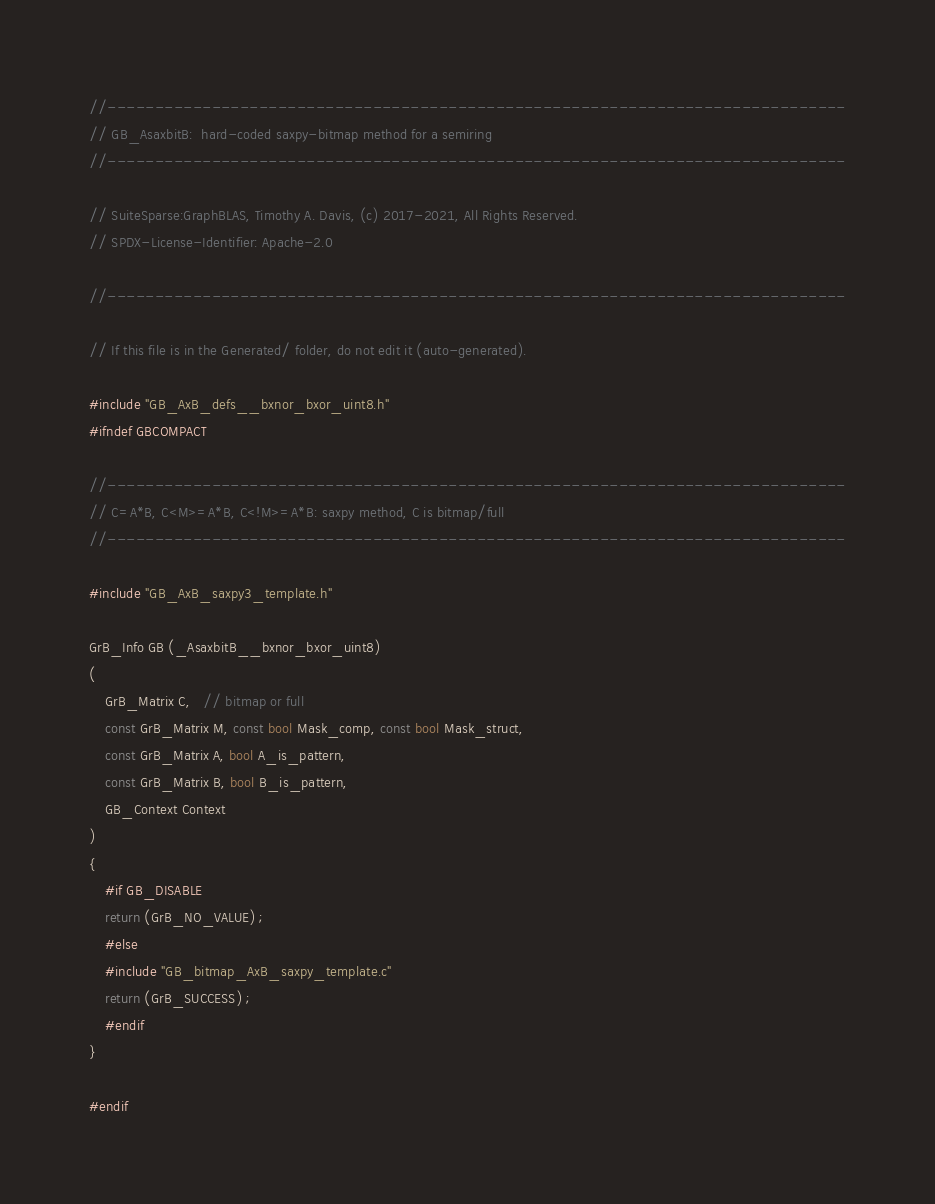Convert code to text. <code><loc_0><loc_0><loc_500><loc_500><_C_>//------------------------------------------------------------------------------
// GB_AsaxbitB:  hard-coded saxpy-bitmap method for a semiring
//------------------------------------------------------------------------------

// SuiteSparse:GraphBLAS, Timothy A. Davis, (c) 2017-2021, All Rights Reserved.
// SPDX-License-Identifier: Apache-2.0

//------------------------------------------------------------------------------

// If this file is in the Generated/ folder, do not edit it (auto-generated).

#include "GB_AxB_defs__bxnor_bxor_uint8.h"
#ifndef GBCOMPACT

//------------------------------------------------------------------------------
// C=A*B, C<M>=A*B, C<!M>=A*B: saxpy method, C is bitmap/full
//------------------------------------------------------------------------------

#include "GB_AxB_saxpy3_template.h"

GrB_Info GB (_AsaxbitB__bxnor_bxor_uint8)
(
    GrB_Matrix C,   // bitmap or full
    const GrB_Matrix M, const bool Mask_comp, const bool Mask_struct,
    const GrB_Matrix A, bool A_is_pattern,
    const GrB_Matrix B, bool B_is_pattern,
    GB_Context Context
)
{ 
    #if GB_DISABLE
    return (GrB_NO_VALUE) ;
    #else
    #include "GB_bitmap_AxB_saxpy_template.c"
    return (GrB_SUCCESS) ;
    #endif
}

#endif

</code> 